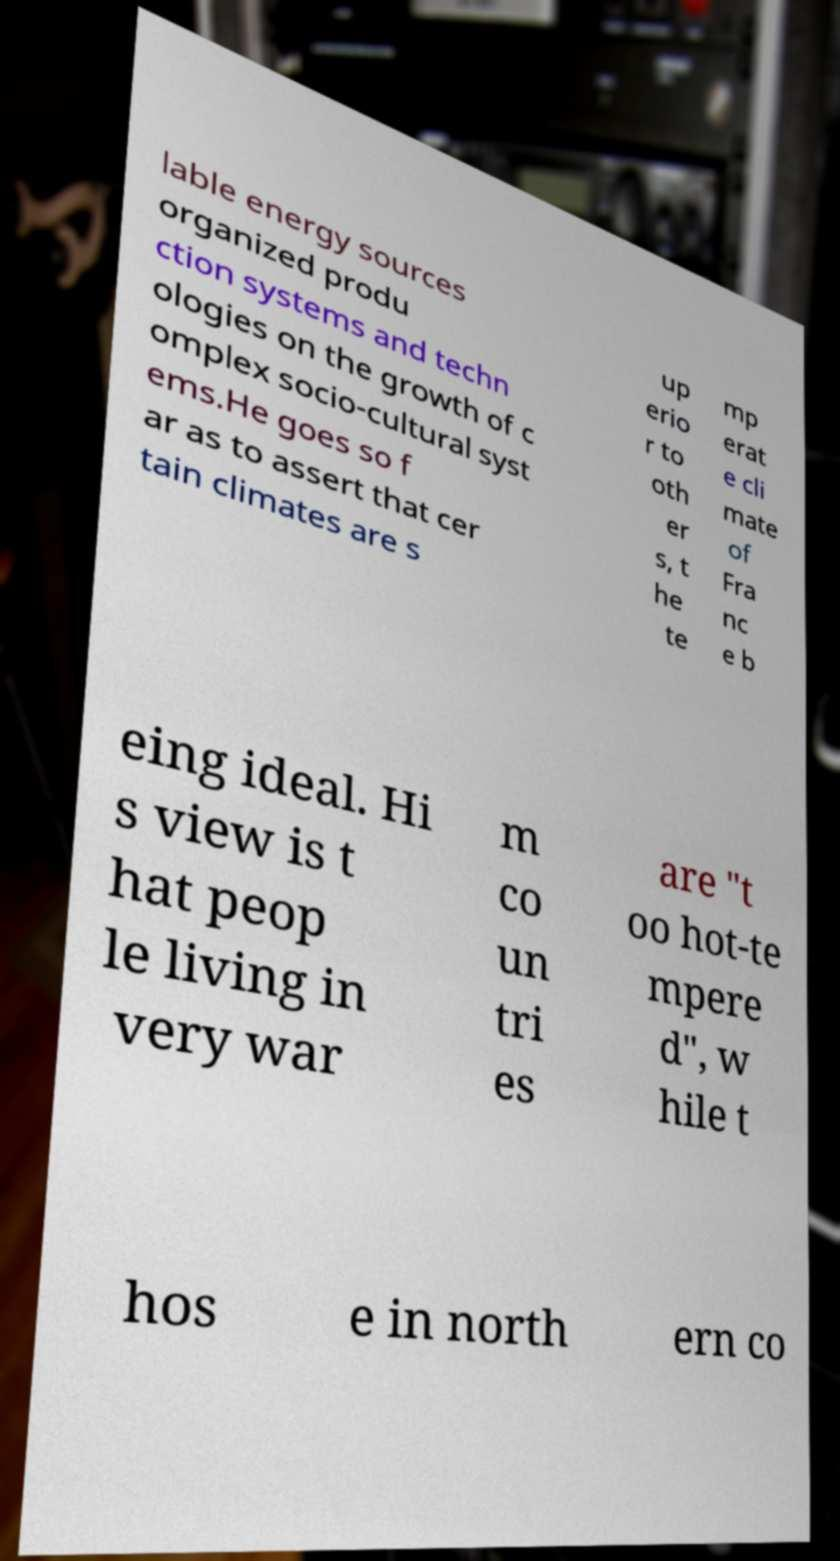There's text embedded in this image that I need extracted. Can you transcribe it verbatim? lable energy sources organized produ ction systems and techn ologies on the growth of c omplex socio-cultural syst ems.He goes so f ar as to assert that cer tain climates are s up erio r to oth er s, t he te mp erat e cli mate of Fra nc e b eing ideal. Hi s view is t hat peop le living in very war m co un tri es are "t oo hot-te mpere d", w hile t hos e in north ern co 